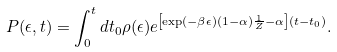Convert formula to latex. <formula><loc_0><loc_0><loc_500><loc_500>P ( \epsilon , t ) = \int _ { 0 } ^ { t } d t _ { 0 } \rho ( \epsilon ) e ^ { \left [ \exp ( - \beta \epsilon ) ( 1 - \alpha ) \frac { 1 } { Z } - \alpha \right ] ( t - t _ { 0 } ) } .</formula> 